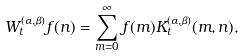<formula> <loc_0><loc_0><loc_500><loc_500>W _ { t } ^ { ( \alpha , \beta ) } f ( n ) = \sum _ { m = 0 } ^ { \infty } f ( m ) K ^ { ( \alpha , \beta ) } _ { t } ( m , n ) ,</formula> 